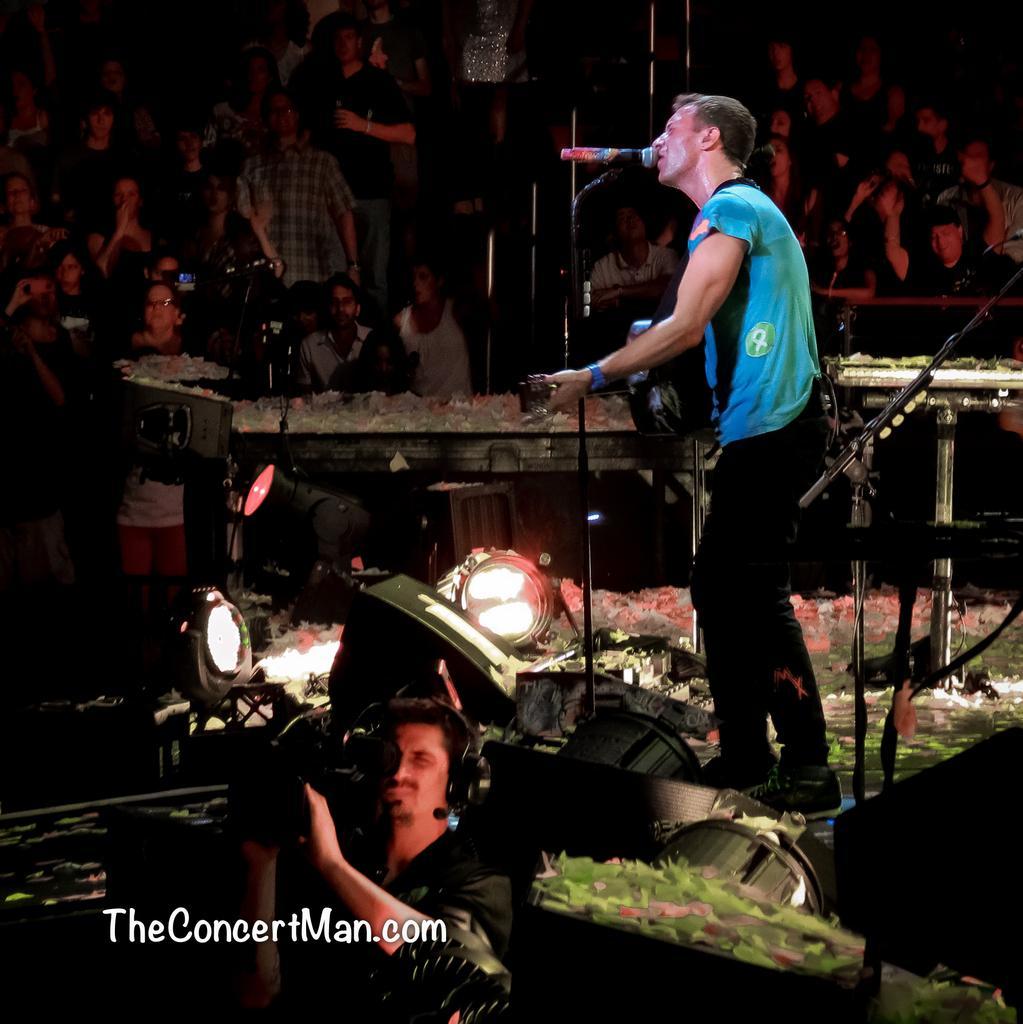Please provide a concise description of this image. This image looks like it is clicked in a concert. In the front, the man wearing a blue T-shirt is singing in the mic. He is also playing a guitar. At the bottom, there is a man holding a camera. In the background, there is a huge crowd. In the middle, there are lights. 